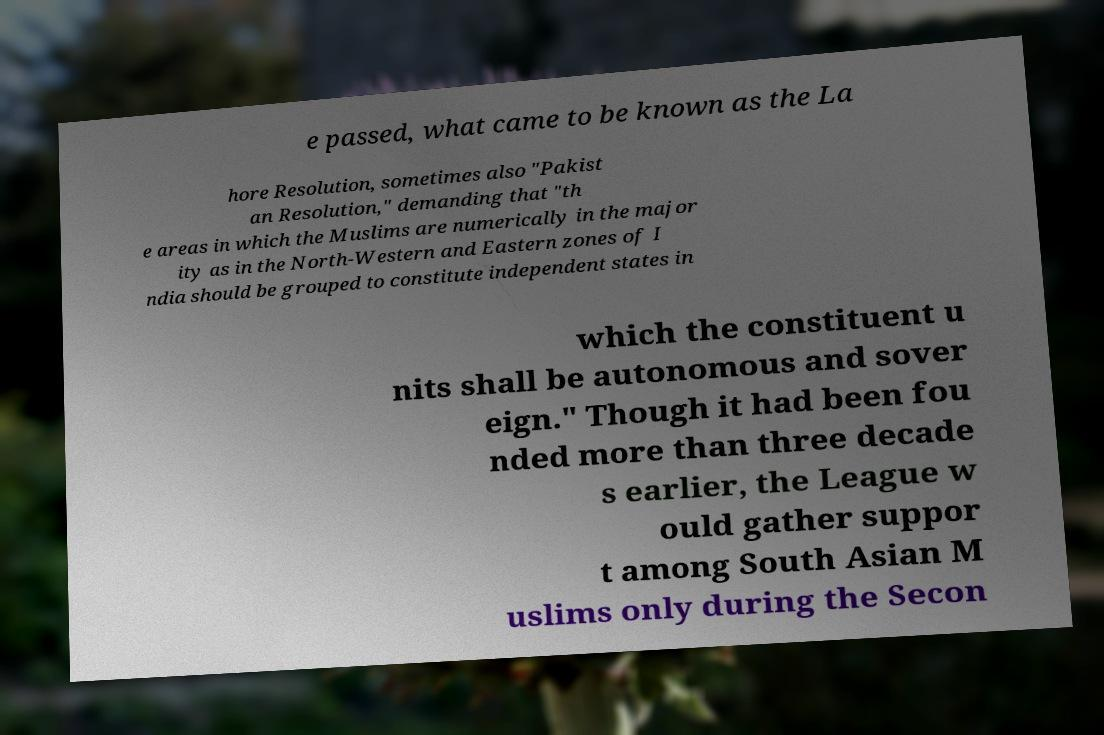Can you accurately transcribe the text from the provided image for me? e passed, what came to be known as the La hore Resolution, sometimes also "Pakist an Resolution," demanding that "th e areas in which the Muslims are numerically in the major ity as in the North-Western and Eastern zones of I ndia should be grouped to constitute independent states in which the constituent u nits shall be autonomous and sover eign." Though it had been fou nded more than three decade s earlier, the League w ould gather suppor t among South Asian M uslims only during the Secon 